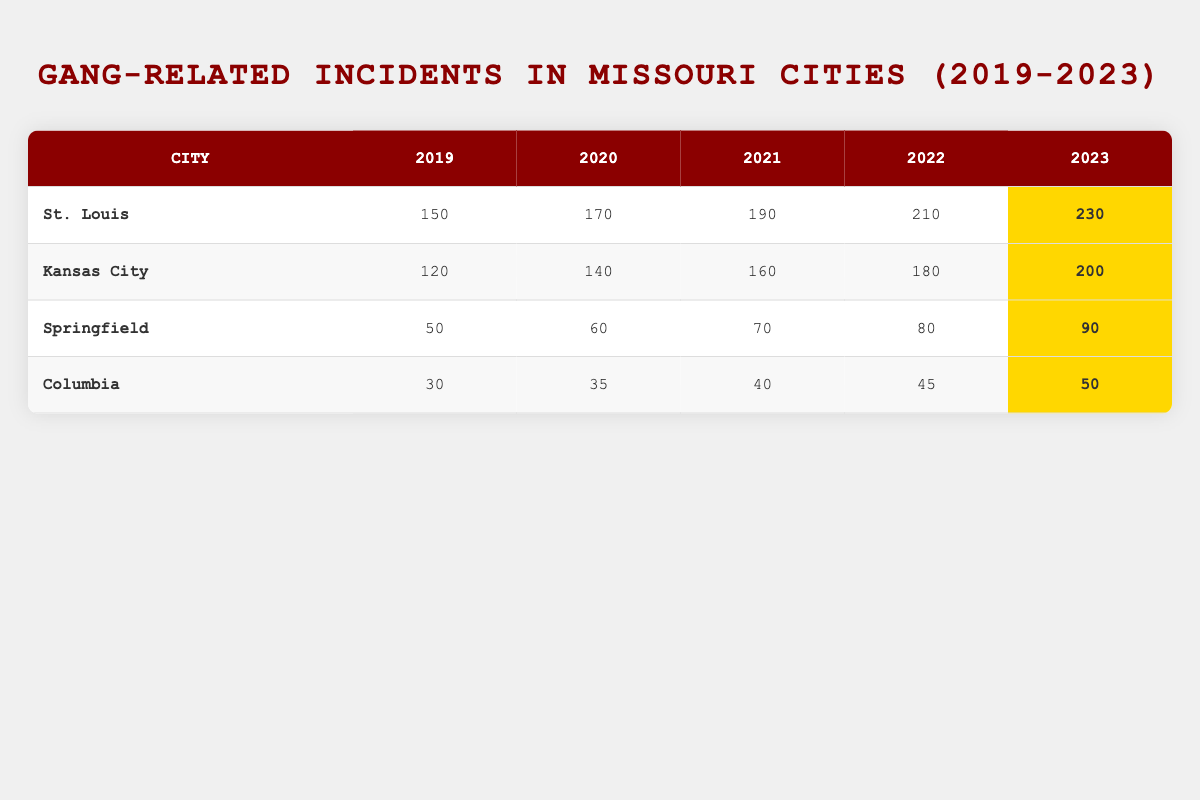What city had the highest number of gang-related incidents in 2023? In the 2023 row of the table, St. Louis shows 230 incidents, which is the highest number when compared to Kansas City (200), Springfield (90), and Columbia (50).
Answer: St. Louis What was the total number of gang-related incidents in Kansas City over the last 5 years? To calculate the total for Kansas City, sum the incidents for each year: 120 + 140 + 160 + 180 + 200 = 800.
Answer: 800 Did Springfield have more gang-related incidents in 2021 than in 2022? In 2021, Springfield had 70 incidents, while in 2022 it had 80 incidents. Since 70 is less than 80, the statement is false.
Answer: No What is the average number of gang-related incidents in St. Louis over the 5 years? St. Louis had the following incidents: 150, 170, 190, 210, 230. Adding these gives 1,050. There are 5 years, so the average is 1,050 / 5 = 210.
Answer: 210 Which city shows the fastest increase in gang-related incidents from 2019 to 2023? Looking at the data, St. Louis increased from 150 in 2019 to 230 in 2023, which is an increase of 80 incidents. Kansas City had an increase of 80 as well (120 to 200), Springfield increased by 40 (50 to 90), and Columbia increased by 20 (30 to 50). Both St. Louis and Kansas City show the same increase, but St. Louis had a consistently higher number.
Answer: St. Louis How many incidents did Columbia have in 2020? From the table, Columbia had 35 incidents listed for the year 2020.
Answer: 35 Did any city experience a decrease in the number of gang-related incidents from 2022 to 2023? When checking the yearly data, all cities have reported an increase in incidents from 2022 to 2023: St. Louis went from 210 to 230, Kansas City from 180 to 200, Springfield from 80 to 90, and Columbia from 45 to 50. Therefore, no city experienced a decrease.
Answer: No What was the total number of gang-related incidents in all cities combined for the year 2021? Adding incidents from all cities in 2021 gives: St. Louis (190) + Kansas City (160) + Springfield (70) + Columbia (40) = 460.
Answer: 460 What is the difference in incidents for St. Louis between 2019 and 2023? St. Louis had 150 incidents in 2019 and 230 in 2023. The difference is 230 - 150 = 80 incidents.
Answer: 80 